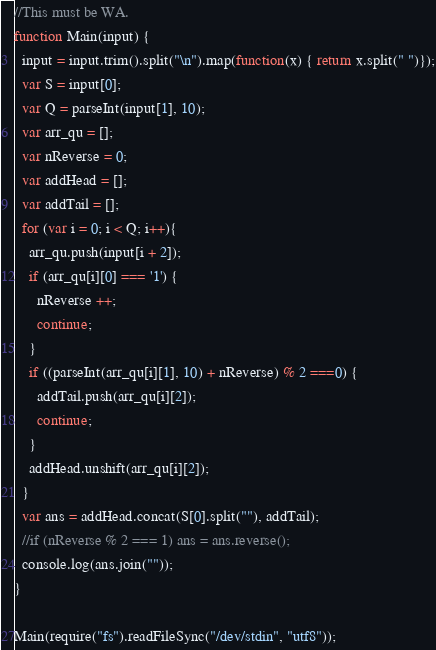<code> <loc_0><loc_0><loc_500><loc_500><_JavaScript_>//This must be WA.
function Main(input) {
  input = input.trim().split("\n").map(function(x) { return x.split(" ")});
  var S = input[0];
  var Q = parseInt(input[1], 10);
  var arr_qu = [];
  var nReverse = 0;
  var addHead = [];
  var addTail = [];
  for (var i = 0; i < Q; i++){
    arr_qu.push(input[i + 2]);
    if (arr_qu[i][0] === '1') {
      nReverse ++;
      continue;
    }
    if ((parseInt(arr_qu[i][1], 10) + nReverse) % 2 ===0) {
      addTail.push(arr_qu[i][2]);
      continue;
    }
    addHead.unshift(arr_qu[i][2]);
  }
  var ans = addHead.concat(S[0].split(""), addTail);
  //if (nReverse % 2 === 1) ans = ans.reverse();
  console.log(ans.join(""));
}   

Main(require("fs").readFileSync("/dev/stdin", "utf8"));</code> 